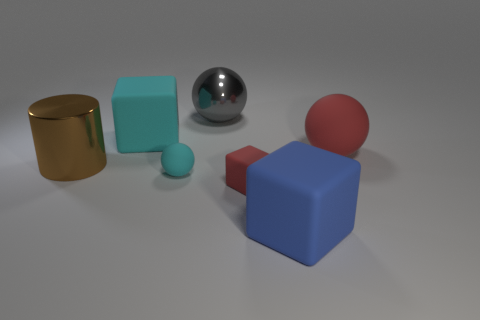Add 1 brown rubber cylinders. How many objects exist? 8 Subtract all blocks. How many objects are left? 4 Subtract all red rubber objects. Subtract all brown metallic things. How many objects are left? 4 Add 4 big red spheres. How many big red spheres are left? 5 Add 3 tiny red rubber cylinders. How many tiny red rubber cylinders exist? 3 Subtract 0 brown balls. How many objects are left? 7 